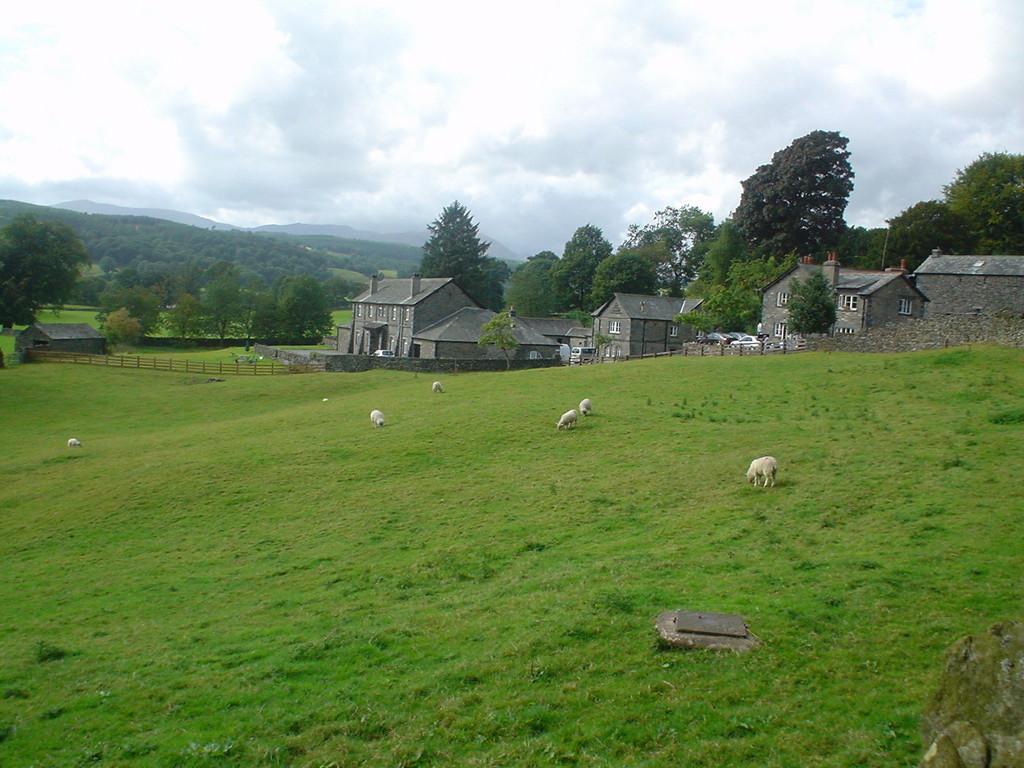Please provide a concise description of this image. In this image there is a ground on which there are sheep´s. In the background there are houses on beside the other. At the top there is the sky. There are trees in between the houses. In the background there are hills on which there are trees. There is a wooden fence around the house. 